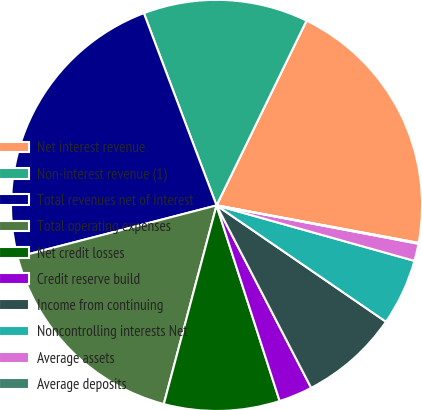<chart> <loc_0><loc_0><loc_500><loc_500><pie_chart><fcel>Net interest revenue<fcel>Non-interest revenue (1)<fcel>Total revenues net of interest<fcel>Total operating expenses<fcel>Net credit losses<fcel>Credit reserve build<fcel>Income from continuing<fcel>Noncontrolling interests Net<fcel>Average assets<fcel>Average deposits<nl><fcel>20.71%<fcel>12.97%<fcel>23.29%<fcel>16.84%<fcel>9.1%<fcel>2.65%<fcel>7.81%<fcel>5.23%<fcel>1.36%<fcel>0.07%<nl></chart> 